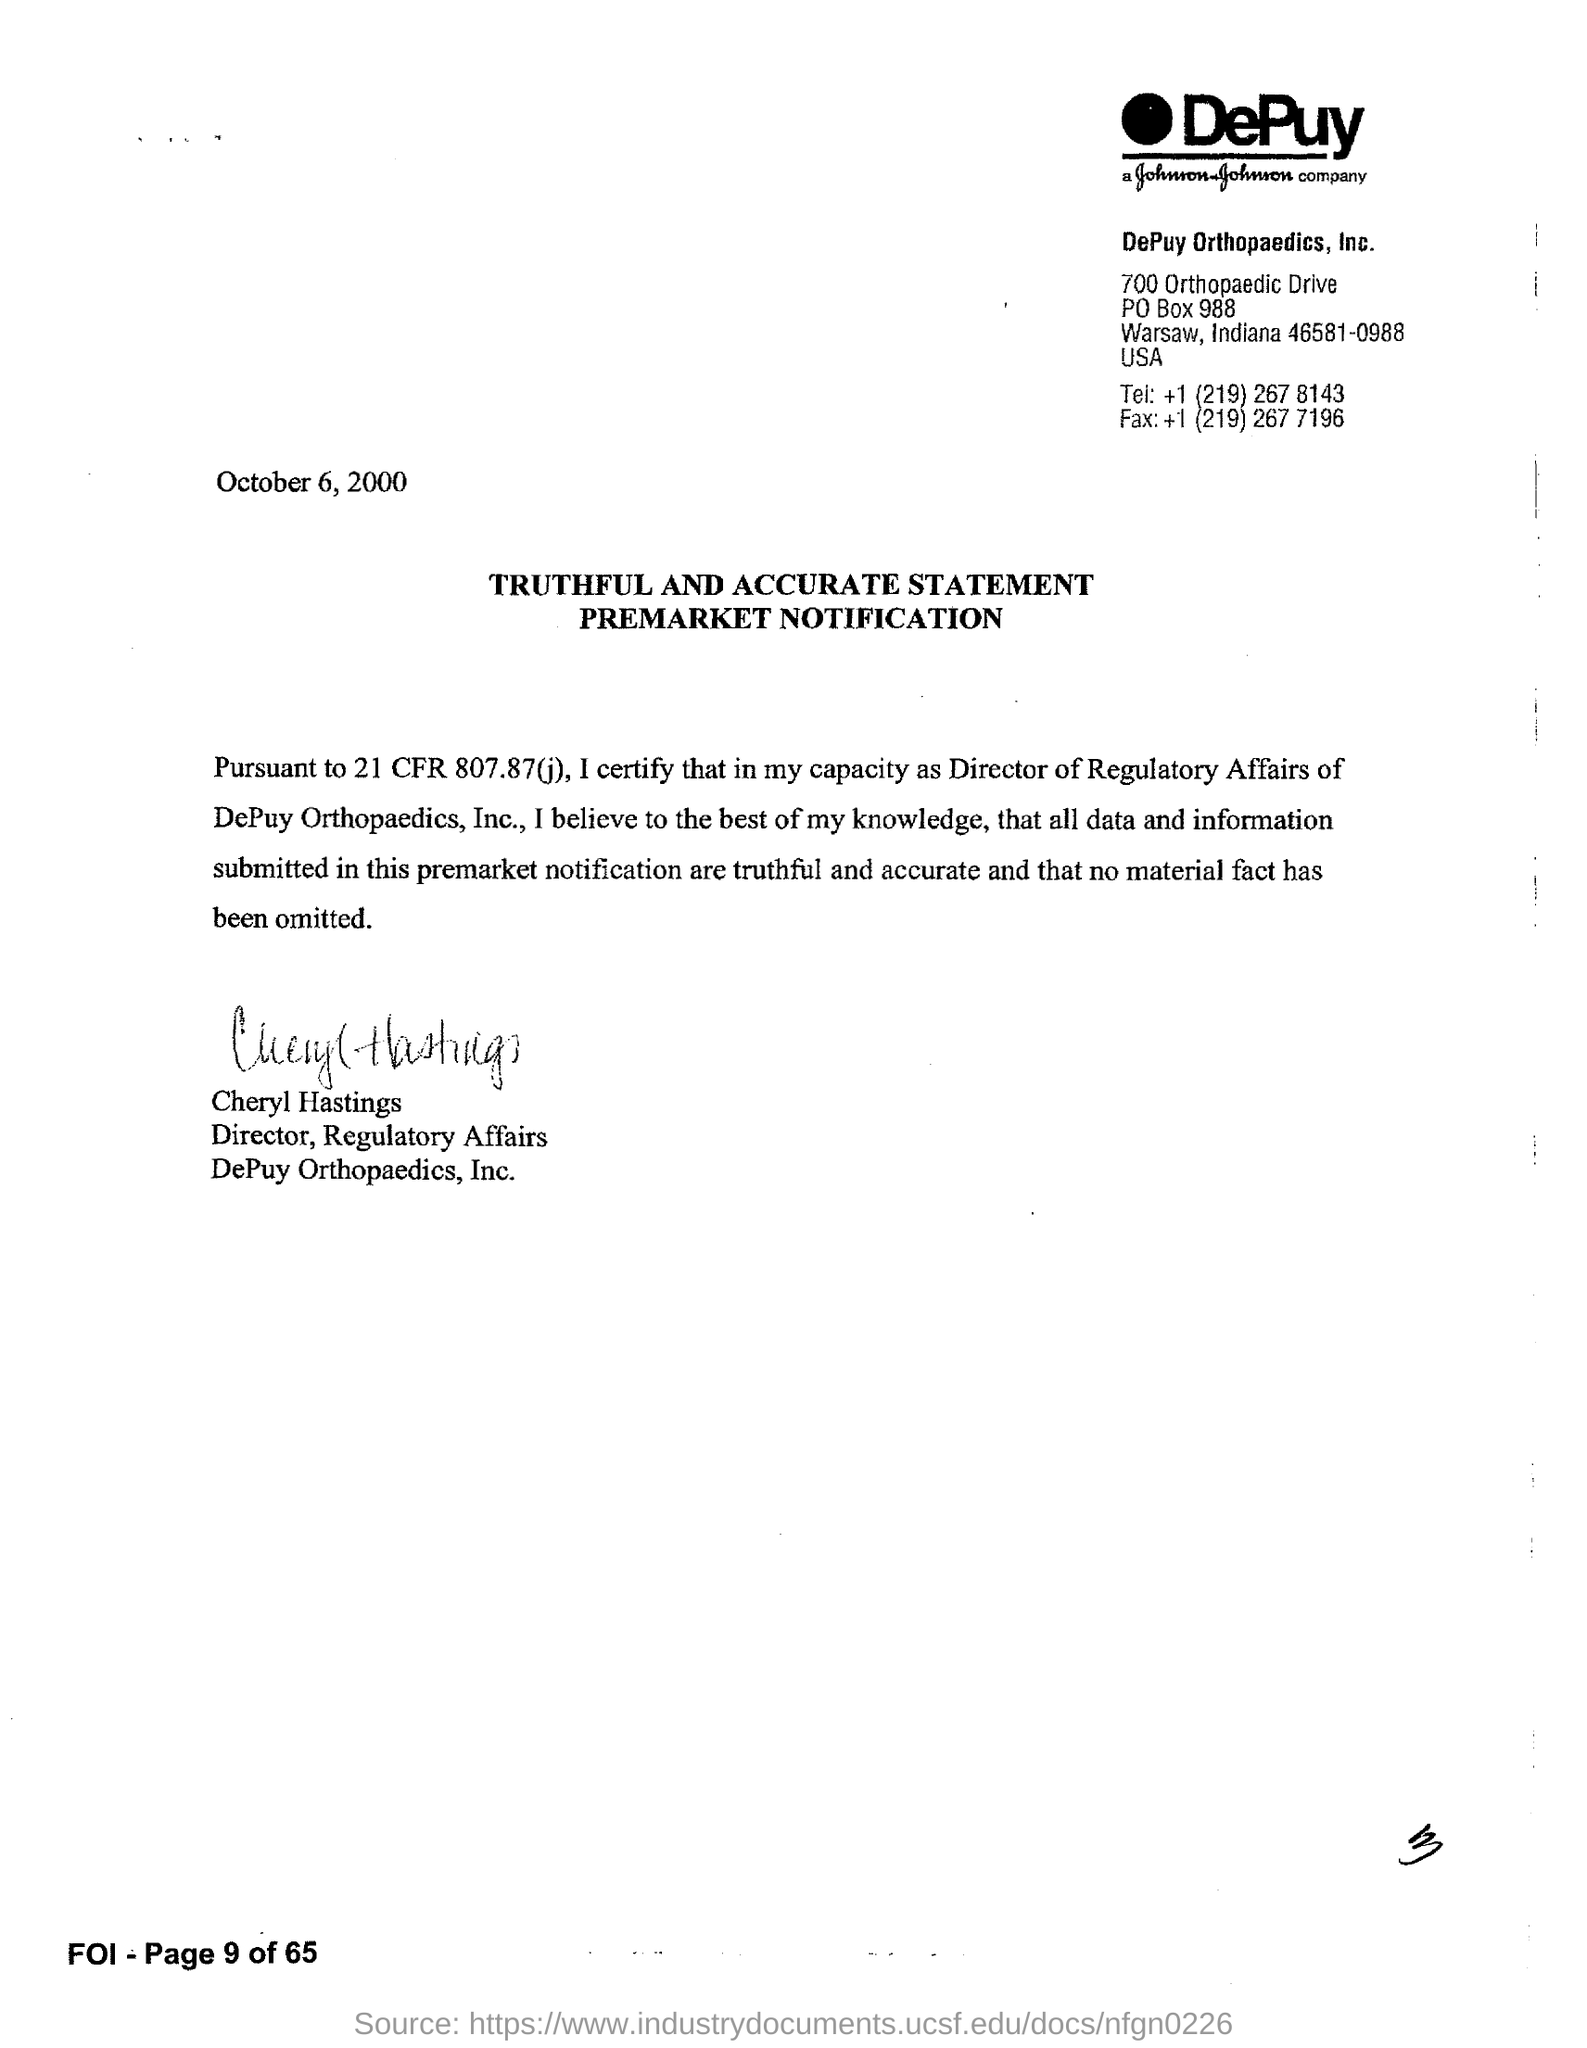What is the date mentioned in this document?
Your response must be concise. OCTOBER 6, 2000. What is the fax no of DePuy Orthopaedics, Inc.?
Make the answer very short. +1 (219) 267 7196. Who has signed this document?
Provide a short and direct response. CHERYL HASTINGS. What is the designation of Cheryl Hastings?
Ensure brevity in your answer.  Director, Regulatory Affairs. 